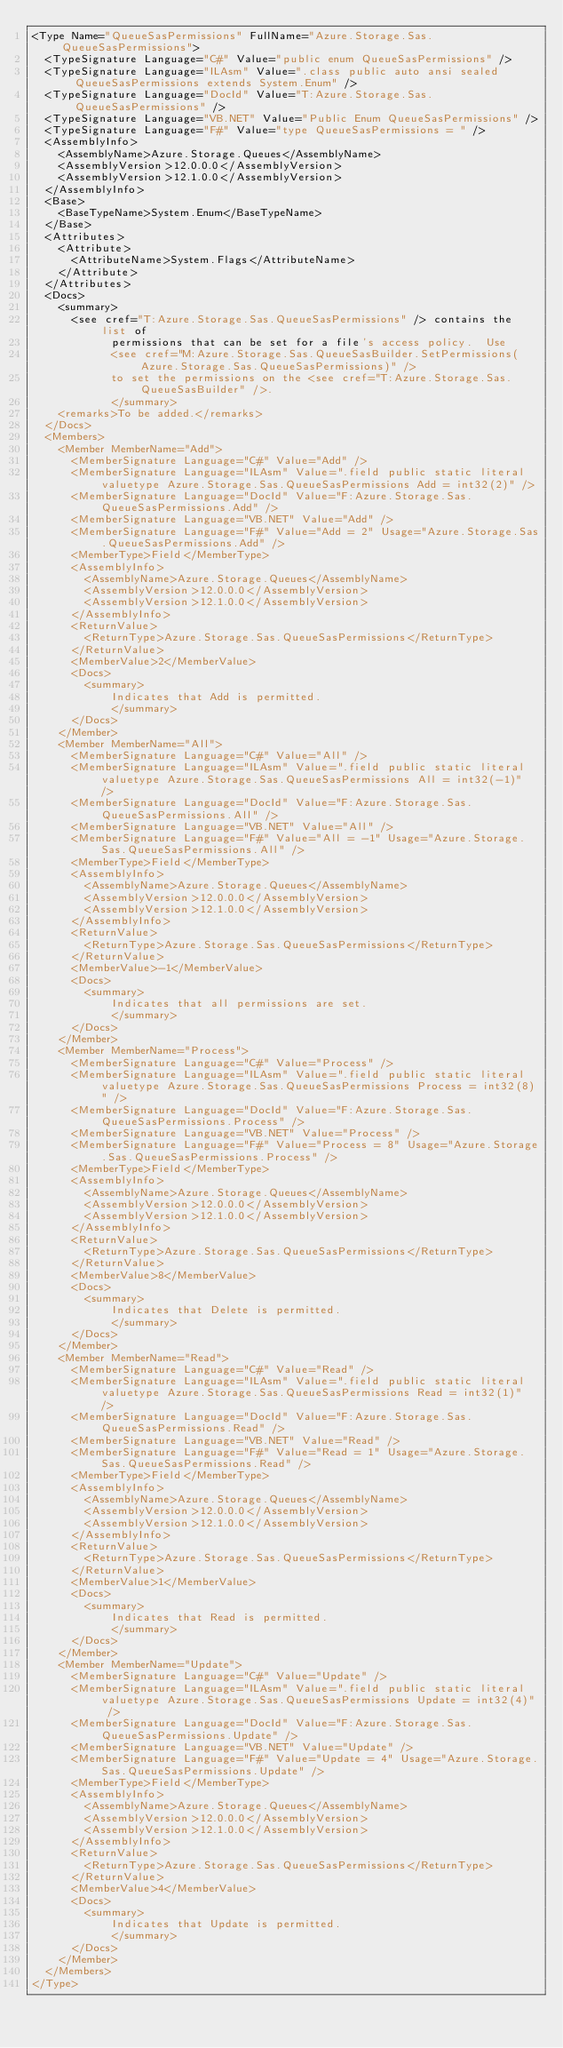<code> <loc_0><loc_0><loc_500><loc_500><_XML_><Type Name="QueueSasPermissions" FullName="Azure.Storage.Sas.QueueSasPermissions">
  <TypeSignature Language="C#" Value="public enum QueueSasPermissions" />
  <TypeSignature Language="ILAsm" Value=".class public auto ansi sealed QueueSasPermissions extends System.Enum" />
  <TypeSignature Language="DocId" Value="T:Azure.Storage.Sas.QueueSasPermissions" />
  <TypeSignature Language="VB.NET" Value="Public Enum QueueSasPermissions" />
  <TypeSignature Language="F#" Value="type QueueSasPermissions = " />
  <AssemblyInfo>
    <AssemblyName>Azure.Storage.Queues</AssemblyName>
    <AssemblyVersion>12.0.0.0</AssemblyVersion>
    <AssemblyVersion>12.1.0.0</AssemblyVersion>
  </AssemblyInfo>
  <Base>
    <BaseTypeName>System.Enum</BaseTypeName>
  </Base>
  <Attributes>
    <Attribute>
      <AttributeName>System.Flags</AttributeName>
    </Attribute>
  </Attributes>
  <Docs>
    <summary>
      <see cref="T:Azure.Storage.Sas.QueueSasPermissions" /> contains the list of
            permissions that can be set for a file's access policy.  Use
            <see cref="M:Azure.Storage.Sas.QueueSasBuilder.SetPermissions(Azure.Storage.Sas.QueueSasPermissions)" />
            to set the permissions on the <see cref="T:Azure.Storage.Sas.QueueSasBuilder" />.
            </summary>
    <remarks>To be added.</remarks>
  </Docs>
  <Members>
    <Member MemberName="Add">
      <MemberSignature Language="C#" Value="Add" />
      <MemberSignature Language="ILAsm" Value=".field public static literal valuetype Azure.Storage.Sas.QueueSasPermissions Add = int32(2)" />
      <MemberSignature Language="DocId" Value="F:Azure.Storage.Sas.QueueSasPermissions.Add" />
      <MemberSignature Language="VB.NET" Value="Add" />
      <MemberSignature Language="F#" Value="Add = 2" Usage="Azure.Storage.Sas.QueueSasPermissions.Add" />
      <MemberType>Field</MemberType>
      <AssemblyInfo>
        <AssemblyName>Azure.Storage.Queues</AssemblyName>
        <AssemblyVersion>12.0.0.0</AssemblyVersion>
        <AssemblyVersion>12.1.0.0</AssemblyVersion>
      </AssemblyInfo>
      <ReturnValue>
        <ReturnType>Azure.Storage.Sas.QueueSasPermissions</ReturnType>
      </ReturnValue>
      <MemberValue>2</MemberValue>
      <Docs>
        <summary>
            Indicates that Add is permitted.
            </summary>
      </Docs>
    </Member>
    <Member MemberName="All">
      <MemberSignature Language="C#" Value="All" />
      <MemberSignature Language="ILAsm" Value=".field public static literal valuetype Azure.Storage.Sas.QueueSasPermissions All = int32(-1)" />
      <MemberSignature Language="DocId" Value="F:Azure.Storage.Sas.QueueSasPermissions.All" />
      <MemberSignature Language="VB.NET" Value="All" />
      <MemberSignature Language="F#" Value="All = -1" Usage="Azure.Storage.Sas.QueueSasPermissions.All" />
      <MemberType>Field</MemberType>
      <AssemblyInfo>
        <AssemblyName>Azure.Storage.Queues</AssemblyName>
        <AssemblyVersion>12.0.0.0</AssemblyVersion>
        <AssemblyVersion>12.1.0.0</AssemblyVersion>
      </AssemblyInfo>
      <ReturnValue>
        <ReturnType>Azure.Storage.Sas.QueueSasPermissions</ReturnType>
      </ReturnValue>
      <MemberValue>-1</MemberValue>
      <Docs>
        <summary>
            Indicates that all permissions are set.
            </summary>
      </Docs>
    </Member>
    <Member MemberName="Process">
      <MemberSignature Language="C#" Value="Process" />
      <MemberSignature Language="ILAsm" Value=".field public static literal valuetype Azure.Storage.Sas.QueueSasPermissions Process = int32(8)" />
      <MemberSignature Language="DocId" Value="F:Azure.Storage.Sas.QueueSasPermissions.Process" />
      <MemberSignature Language="VB.NET" Value="Process" />
      <MemberSignature Language="F#" Value="Process = 8" Usage="Azure.Storage.Sas.QueueSasPermissions.Process" />
      <MemberType>Field</MemberType>
      <AssemblyInfo>
        <AssemblyName>Azure.Storage.Queues</AssemblyName>
        <AssemblyVersion>12.0.0.0</AssemblyVersion>
        <AssemblyVersion>12.1.0.0</AssemblyVersion>
      </AssemblyInfo>
      <ReturnValue>
        <ReturnType>Azure.Storage.Sas.QueueSasPermissions</ReturnType>
      </ReturnValue>
      <MemberValue>8</MemberValue>
      <Docs>
        <summary>
            Indicates that Delete is permitted.
            </summary>
      </Docs>
    </Member>
    <Member MemberName="Read">
      <MemberSignature Language="C#" Value="Read" />
      <MemberSignature Language="ILAsm" Value=".field public static literal valuetype Azure.Storage.Sas.QueueSasPermissions Read = int32(1)" />
      <MemberSignature Language="DocId" Value="F:Azure.Storage.Sas.QueueSasPermissions.Read" />
      <MemberSignature Language="VB.NET" Value="Read" />
      <MemberSignature Language="F#" Value="Read = 1" Usage="Azure.Storage.Sas.QueueSasPermissions.Read" />
      <MemberType>Field</MemberType>
      <AssemblyInfo>
        <AssemblyName>Azure.Storage.Queues</AssemblyName>
        <AssemblyVersion>12.0.0.0</AssemblyVersion>
        <AssemblyVersion>12.1.0.0</AssemblyVersion>
      </AssemblyInfo>
      <ReturnValue>
        <ReturnType>Azure.Storage.Sas.QueueSasPermissions</ReturnType>
      </ReturnValue>
      <MemberValue>1</MemberValue>
      <Docs>
        <summary>
            Indicates that Read is permitted.
            </summary>
      </Docs>
    </Member>
    <Member MemberName="Update">
      <MemberSignature Language="C#" Value="Update" />
      <MemberSignature Language="ILAsm" Value=".field public static literal valuetype Azure.Storage.Sas.QueueSasPermissions Update = int32(4)" />
      <MemberSignature Language="DocId" Value="F:Azure.Storage.Sas.QueueSasPermissions.Update" />
      <MemberSignature Language="VB.NET" Value="Update" />
      <MemberSignature Language="F#" Value="Update = 4" Usage="Azure.Storage.Sas.QueueSasPermissions.Update" />
      <MemberType>Field</MemberType>
      <AssemblyInfo>
        <AssemblyName>Azure.Storage.Queues</AssemblyName>
        <AssemblyVersion>12.0.0.0</AssemblyVersion>
        <AssemblyVersion>12.1.0.0</AssemblyVersion>
      </AssemblyInfo>
      <ReturnValue>
        <ReturnType>Azure.Storage.Sas.QueueSasPermissions</ReturnType>
      </ReturnValue>
      <MemberValue>4</MemberValue>
      <Docs>
        <summary>
            Indicates that Update is permitted.
            </summary>
      </Docs>
    </Member>
  </Members>
</Type>
</code> 